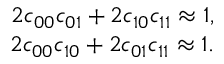<formula> <loc_0><loc_0><loc_500><loc_500>\begin{array} { r } { 2 c _ { 0 0 } c _ { 0 1 } + 2 c _ { 1 0 } c _ { 1 1 } \approx 1 , } \\ { 2 c _ { 0 0 } c _ { 1 0 } + 2 c _ { 0 1 } c _ { 1 1 } \approx 1 . } \end{array}</formula> 